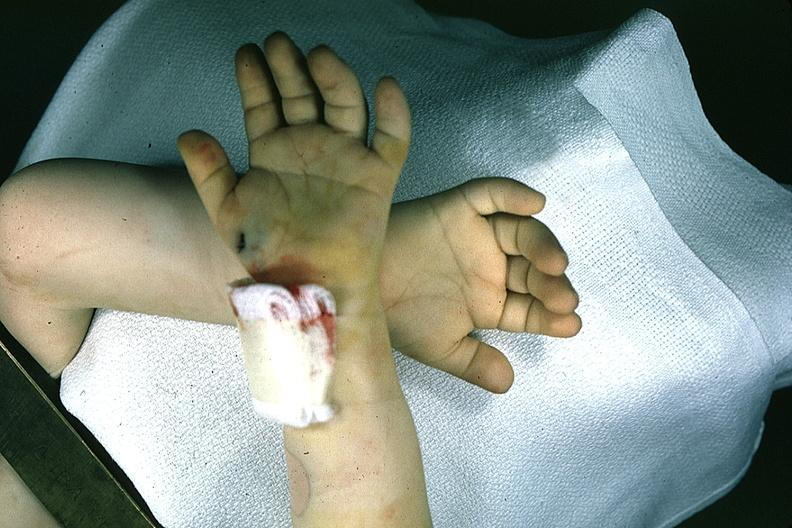re extremities present?
Answer the question using a single word or phrase. Yes 